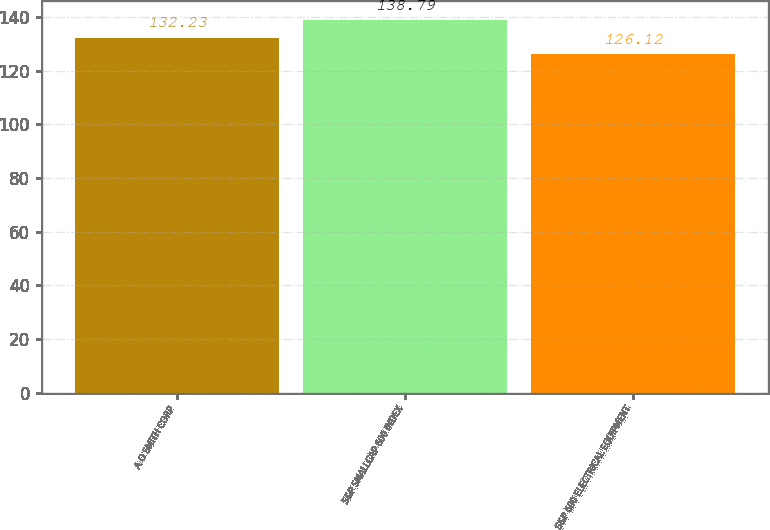Convert chart. <chart><loc_0><loc_0><loc_500><loc_500><bar_chart><fcel>A O SMITH CORP<fcel>S&P SMALLCAP 600 INDEX<fcel>S&P 600 ELECTRICAL EQUIPMENT<nl><fcel>132.23<fcel>138.79<fcel>126.12<nl></chart> 